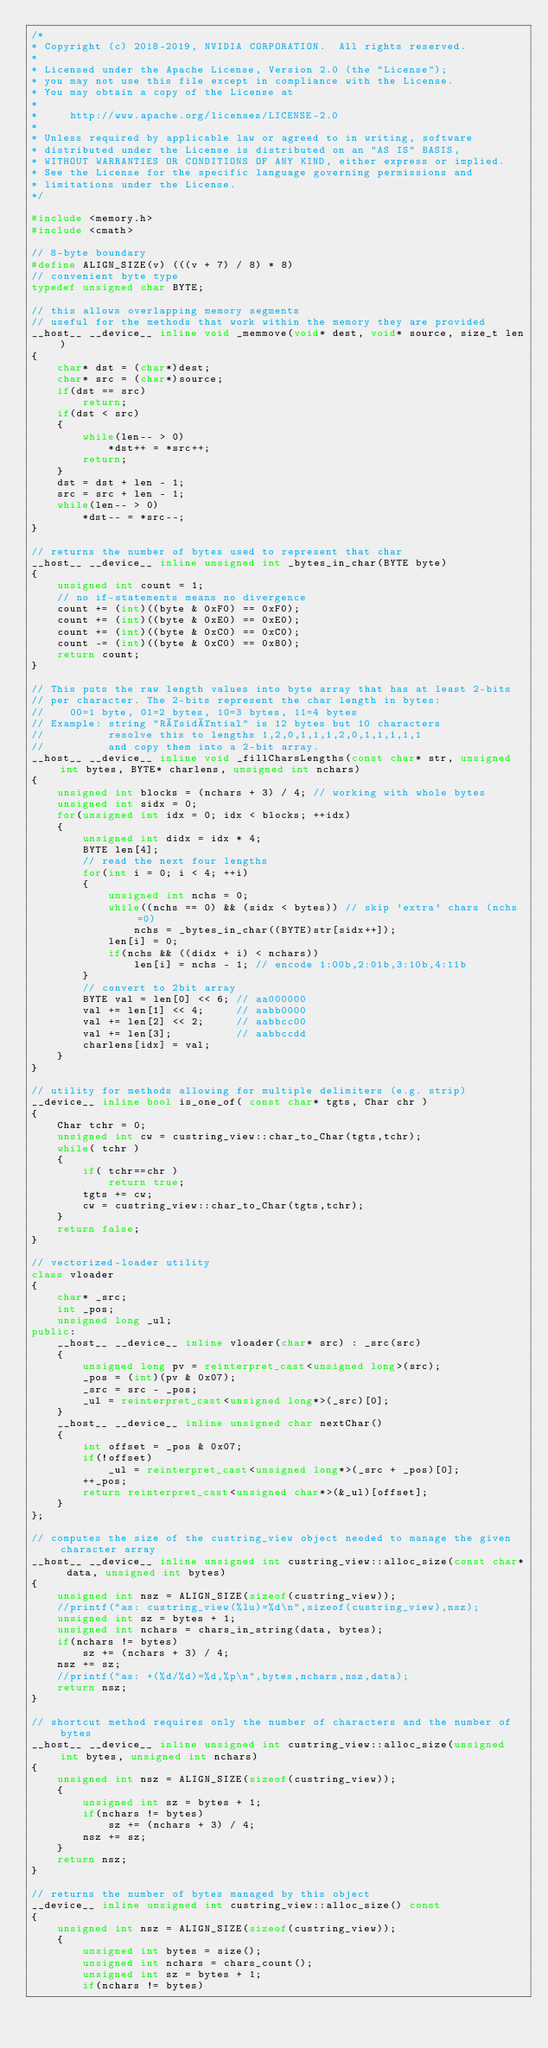<code> <loc_0><loc_0><loc_500><loc_500><_C++_>/*
* Copyright (c) 2018-2019, NVIDIA CORPORATION.  All rights reserved.
*
* Licensed under the Apache License, Version 2.0 (the "License");
* you may not use this file except in compliance with the License.
* You may obtain a copy of the License at
*
*     http://www.apache.org/licenses/LICENSE-2.0
*
* Unless required by applicable law or agreed to in writing, software
* distributed under the License is distributed on an "AS IS" BASIS,
* WITHOUT WARRANTIES OR CONDITIONS OF ANY KIND, either express or implied.
* See the License for the specific language governing permissions and
* limitations under the License.
*/

#include <memory.h>
#include <cmath>

// 8-byte boundary
#define ALIGN_SIZE(v) (((v + 7) / 8) * 8)
// convenient byte type
typedef unsigned char BYTE;

// this allows overlapping memory segments
// useful for the methods that work within the memory they are provided
__host__ __device__ inline void _memmove(void* dest, void* source, size_t len)
{
    char* dst = (char*)dest;
    char* src = (char*)source;
    if(dst == src)
        return;
    if(dst < src)
    {
        while(len-- > 0)
            *dst++ = *src++;
        return;
    }
    dst = dst + len - 1;
    src = src + len - 1;
    while(len-- > 0)
        *dst-- = *src--;
}

// returns the number of bytes used to represent that char
__host__ __device__ inline unsigned int _bytes_in_char(BYTE byte)
{
    unsigned int count = 1;
    // no if-statements means no divergence
    count += (int)((byte & 0xF0) == 0xF0);
    count += (int)((byte & 0xE0) == 0xE0);
    count += (int)((byte & 0xC0) == 0xC0);
    count -= (int)((byte & 0xC0) == 0x80);
    return count;
}

// This puts the raw length values into byte array that has at least 2-bits
// per character. The 2-bits represent the char length in bytes:
//    00=1 byte, 01=2 bytes, 10=3 bytes, 11=4 bytes
// Example: string "Résidéntial" is 12 bytes but 10 characters
//          resolve this to lengths 1,2,0,1,1,1,2,0,1,1,1,1,1
//          and copy them into a 2-bit array.
__host__ __device__ inline void _fillCharsLengths(const char* str, unsigned int bytes, BYTE* charlens, unsigned int nchars)
{
    unsigned int blocks = (nchars + 3) / 4; // working with whole bytes
    unsigned int sidx = 0;
    for(unsigned int idx = 0; idx < blocks; ++idx)
    {
        unsigned int didx = idx * 4;
        BYTE len[4];
        // read the next four lengths
        for(int i = 0; i < 4; ++i)
        {
            unsigned int nchs = 0;
            while((nchs == 0) && (sidx < bytes)) // skip 'extra' chars (nchs=0)
                nchs = _bytes_in_char((BYTE)str[sidx++]);
            len[i] = 0;
            if(nchs && ((didx + i) < nchars))
                len[i] = nchs - 1; // encode 1:00b,2:01b,3:10b,4:11b
        }
        // convert to 2bit array
        BYTE val = len[0] << 6; // aa000000
        val += len[1] << 4;     // aabb0000
        val += len[2] << 2;     // aabbcc00
        val += len[3];          // aabbccdd
        charlens[idx] = val;
    }
}

// utility for methods allowing for multiple delimiters (e.g. strip)
__device__ inline bool is_one_of( const char* tgts, Char chr )
{
    Char tchr = 0;
    unsigned int cw = custring_view::char_to_Char(tgts,tchr);
    while( tchr )
    {
        if( tchr==chr )
            return true;
        tgts += cw;
        cw = custring_view::char_to_Char(tgts,tchr);
    }
    return false;
}

// vectorized-loader utility
class vloader
{
    char* _src;
    int _pos;
    unsigned long _ul;
public:
    __host__ __device__ inline vloader(char* src) : _src(src)
    {
        unsigned long pv = reinterpret_cast<unsigned long>(src);
        _pos = (int)(pv & 0x07);
        _src = src - _pos;
        _ul = reinterpret_cast<unsigned long*>(_src)[0];
    }
    __host__ __device__ inline unsigned char nextChar()
    {
        int offset = _pos & 0x07;
        if(!offset)
            _ul = reinterpret_cast<unsigned long*>(_src + _pos)[0];
        ++_pos;
        return reinterpret_cast<unsigned char*>(&_ul)[offset];
    }
};

// computes the size of the custring_view object needed to manage the given character array
__host__ __device__ inline unsigned int custring_view::alloc_size(const char* data, unsigned int bytes)
{
    unsigned int nsz = ALIGN_SIZE(sizeof(custring_view));
    //printf("as: custring_view(%lu)=%d\n",sizeof(custring_view),nsz);
    unsigned int sz = bytes + 1;
    unsigned int nchars = chars_in_string(data, bytes);
    if(nchars != bytes)
        sz += (nchars + 3) / 4;
    nsz += sz;
    //printf("as: +(%d/%d)=%d,%p\n",bytes,nchars,nsz,data);
    return nsz;
}

// shortcut method requires only the number of characters and the number of bytes
__host__ __device__ inline unsigned int custring_view::alloc_size(unsigned int bytes, unsigned int nchars)
{
    unsigned int nsz = ALIGN_SIZE(sizeof(custring_view));
    {
        unsigned int sz = bytes + 1;
        if(nchars != bytes)
            sz += (nchars + 3) / 4;
        nsz += sz;
    }
    return nsz;
}

// returns the number of bytes managed by this object
__device__ inline unsigned int custring_view::alloc_size() const
{
    unsigned int nsz = ALIGN_SIZE(sizeof(custring_view));
    {
        unsigned int bytes = size();
        unsigned int nchars = chars_count();
        unsigned int sz = bytes + 1;
        if(nchars != bytes)</code> 